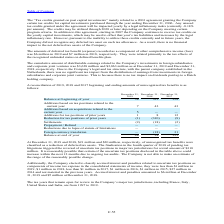From Stmicroelectronics's financial document, How much unrecognized tax benefits were classified as a reduction of deferred tax assets as of December 31, 2019 and 2018? The document shows two values: $21 million and $20 million. From the document: "At December 31, 2019 and 2018, $21 million and $20 million, respectively, of unrecognized tax benefits were classified as a reduction of deferred tax ..." Also, How much was the Accrued interest and penalties as of December 31, 2019? According to the financial document, $6 million. The relevant text states: "component of other comprehensive income (loss) was $6 million in 2019 and $7 million in 2018, respectively. They were related primarily to the tax effects of the..." Also, How much was the Accrued interest and penalties as of December 31, 2019? According to the financial document, $5 million. The relevant text states: "es amounted to $6 million at December 31, 2019 and $5 million at December 31, 2018...." Also, can you calculate: What is the increase/ (decrease) in Balance at beginning of year from December 31, 2018 to 2019? Based on the calculation: 38-333, the result is -295 (in millions). This is based on the information: "Balance at beginning of year 38 333 258 Balance at beginning of year 38 333 258..." The key data points involved are: 333, 38. Also, can you calculate: What is the increase/ (decrease) in Balance at end of year from December 31, 2018 to 2019? Based on the calculation: 48-38, the result is 10 (in millions). This is based on the information: "Balance at end of year 48 38 333 Balance at end of year 48 38 333..." The key data points involved are: 38, 48. Also, can you calculate: What is the increase/ (decrease) in Settlements from December 31, 2018 to 2019? Based on the calculation: 2-18, the result is -16 (in millions). This is based on the information: "early by a legal inflationary index (currently -0.18% per annum). The credits may be utilized through 2020 or later depending on the Company meeting cer early by a legal inflationary index (currently ..." The key data points involved are: 18, 2. 